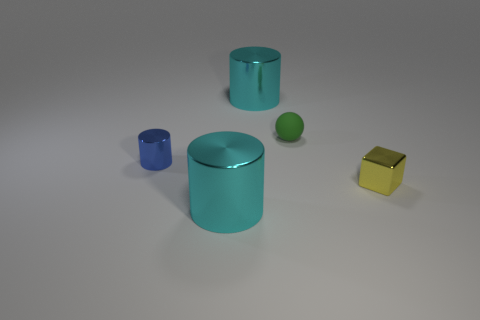Is there a large yellow matte thing?
Offer a very short reply. No. Does the cyan cylinder that is in front of the green ball have the same material as the thing that is right of the tiny green ball?
Offer a terse response. Yes. What number of things are cyan cylinders behind the tiny green sphere or cyan metal cylinders that are behind the small blue metallic cylinder?
Your answer should be compact. 1. Does the cylinder behind the small cylinder have the same color as the shiny cylinder in front of the small shiny cube?
Keep it short and to the point. Yes. There is a metallic thing that is both on the right side of the small cylinder and behind the tiny yellow object; what is its shape?
Offer a terse response. Cylinder. There is another matte object that is the same size as the yellow thing; what color is it?
Your response must be concise. Green. Is there a large metallic cylinder that has the same color as the block?
Your answer should be compact. No. There is a cyan metal cylinder that is in front of the blue object; does it have the same size as the rubber thing that is on the left side of the block?
Offer a terse response. No. There is a small object that is on the right side of the tiny cylinder and on the left side of the yellow cube; what is its material?
Provide a short and direct response. Rubber. How many other objects are there of the same size as the blue shiny cylinder?
Your answer should be compact. 2. 